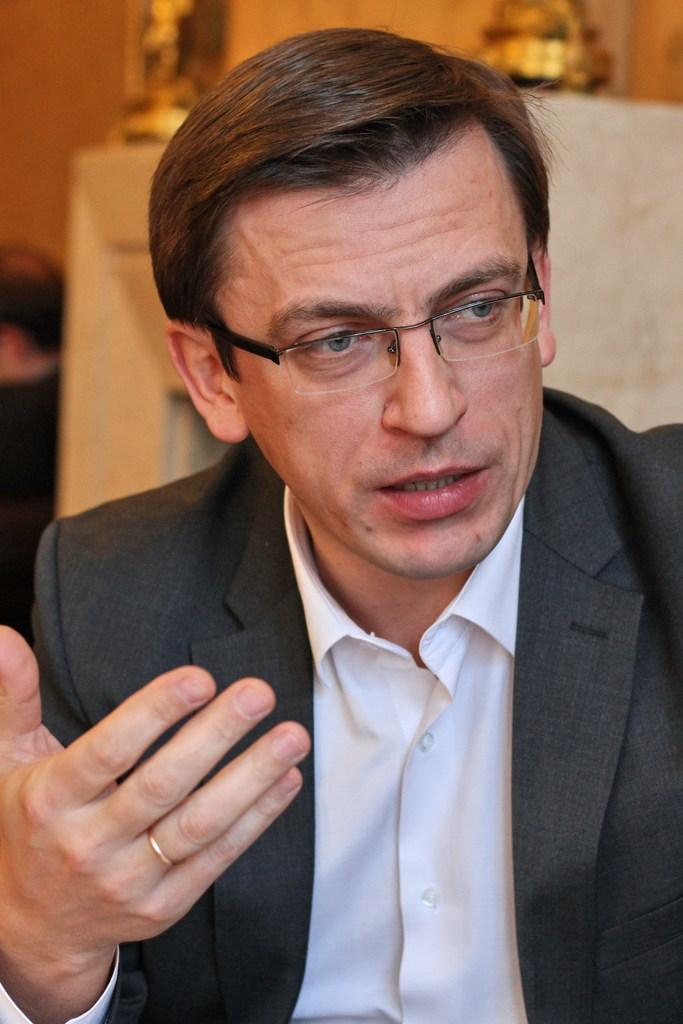Who is present in the image? There is a man present in the image. What is the man wearing on his face? The man is wearing spectacles. What color is the shirt the man is wearing? The man is wearing a white shirt. What type of outerwear is the man wearing? The man is wearing a blazer. What type of food is the man eating in the image? There is no food present in the image, so it cannot be determined what the man might be eating. 